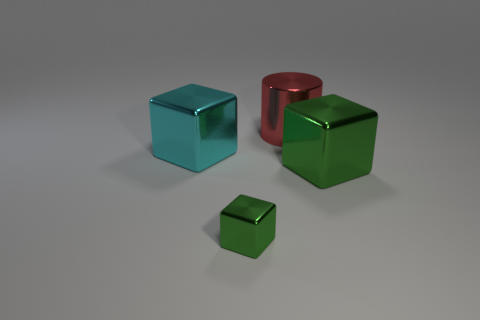Subtract all big cubes. How many cubes are left? 1 Subtract all green cubes. How many cubes are left? 1 Subtract all cubes. How many objects are left? 1 Subtract all cyan cubes. How many purple cylinders are left? 0 Subtract all large shiny cylinders. Subtract all metal cylinders. How many objects are left? 2 Add 3 small green things. How many small green things are left? 4 Add 4 green metal things. How many green metal things exist? 6 Add 1 red cylinders. How many objects exist? 5 Subtract 0 gray cylinders. How many objects are left? 4 Subtract 2 blocks. How many blocks are left? 1 